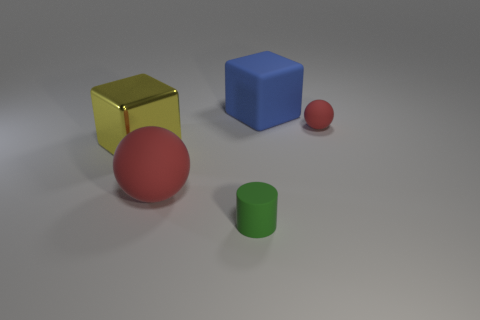There is a cylinder; is its color the same as the tiny thing behind the large yellow metal cube?
Your answer should be very brief. No. How many large cyan metallic blocks are there?
Make the answer very short. 0. Are there any large metallic cubes of the same color as the tiny cylinder?
Ensure brevity in your answer.  No. There is a small object that is right of the object that is in front of the red matte thing that is in front of the large shiny cube; what is its color?
Provide a succinct answer. Red. Does the big red ball have the same material as the big block behind the small red matte thing?
Offer a terse response. Yes. What is the blue object made of?
Provide a succinct answer. Rubber. There is a object that is the same color as the small ball; what is it made of?
Your response must be concise. Rubber. What number of other objects are there of the same material as the large ball?
Make the answer very short. 3. There is a matte thing that is to the left of the blue cube and on the right side of the large red ball; what shape is it?
Your answer should be compact. Cylinder. What is the color of the tiny sphere that is the same material as the large red ball?
Your answer should be very brief. Red. 